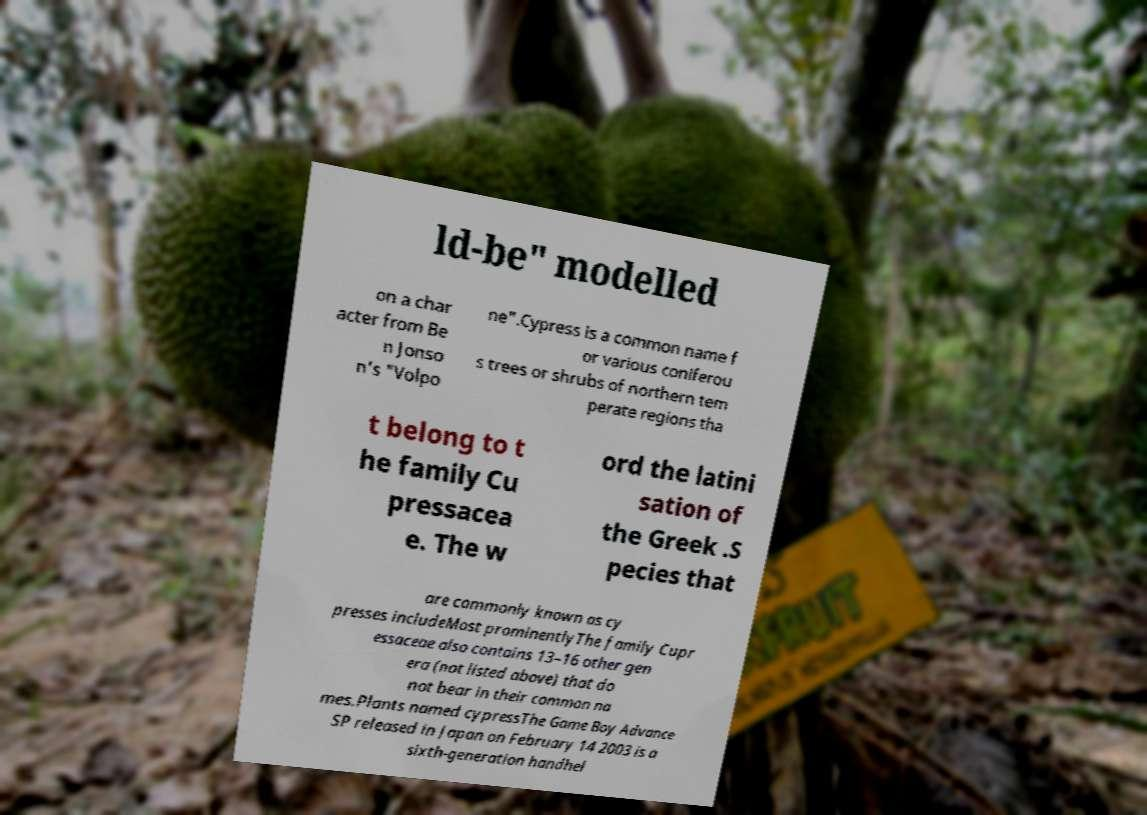Please read and relay the text visible in this image. What does it say? ld-be" modelled on a char acter from Be n Jonso n's "Volpo ne".Cypress is a common name f or various coniferou s trees or shrubs of northern tem perate regions tha t belong to t he family Cu pressacea e. The w ord the latini sation of the Greek .S pecies that are commonly known as cy presses includeMost prominentlyThe family Cupr essaceae also contains 13–16 other gen era (not listed above) that do not bear in their common na mes.Plants named cypressThe Game Boy Advance SP released in Japan on February 14 2003 is a sixth-generation handhel 